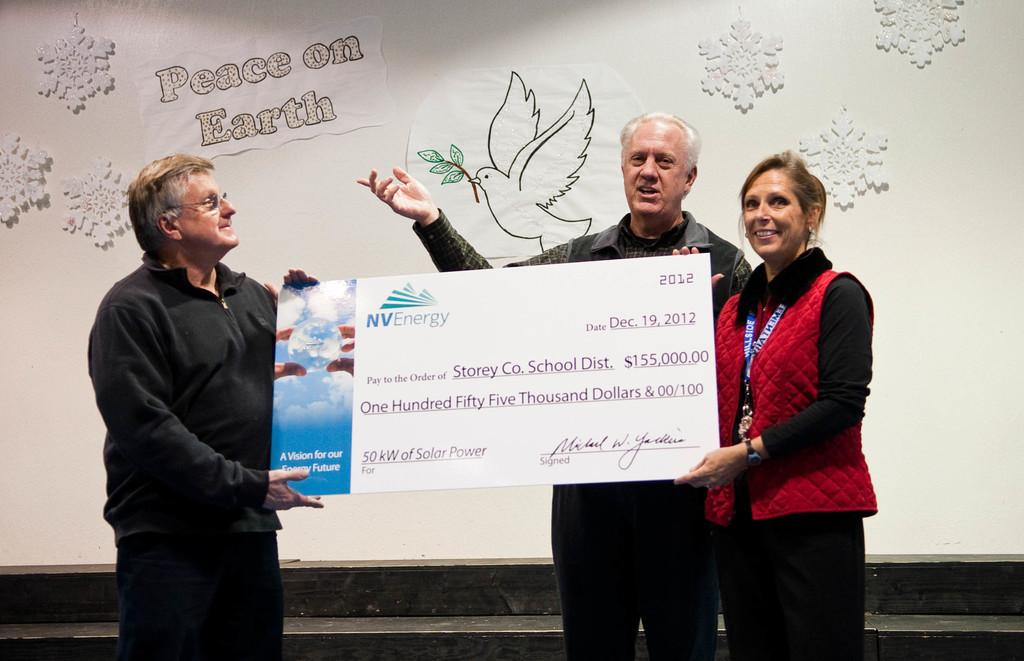How many people are in the image? There are three persons in the image. What are the persons holding in the image? The persons are holding a cheque. What can be seen in the background of the image? There is a wall in the background of the image. What is on the wall in the background? There are posters on the wall in the background. What type of bead is used to decorate the cheque in the image? There is no bead present on the cheque in the image. Can you hear the persons talking in the image? The image is a still photograph, so it does not capture any sounds or conversations. 